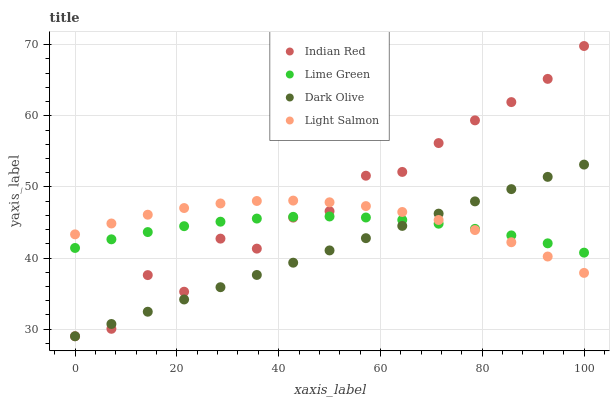Does Dark Olive have the minimum area under the curve?
Answer yes or no. Yes. Does Indian Red have the maximum area under the curve?
Answer yes or no. Yes. Does Lime Green have the minimum area under the curve?
Answer yes or no. No. Does Lime Green have the maximum area under the curve?
Answer yes or no. No. Is Dark Olive the smoothest?
Answer yes or no. Yes. Is Indian Red the roughest?
Answer yes or no. Yes. Is Lime Green the smoothest?
Answer yes or no. No. Is Lime Green the roughest?
Answer yes or no. No. Does Dark Olive have the lowest value?
Answer yes or no. Yes. Does Lime Green have the lowest value?
Answer yes or no. No. Does Indian Red have the highest value?
Answer yes or no. Yes. Does Dark Olive have the highest value?
Answer yes or no. No. Does Dark Olive intersect Indian Red?
Answer yes or no. Yes. Is Dark Olive less than Indian Red?
Answer yes or no. No. Is Dark Olive greater than Indian Red?
Answer yes or no. No. 